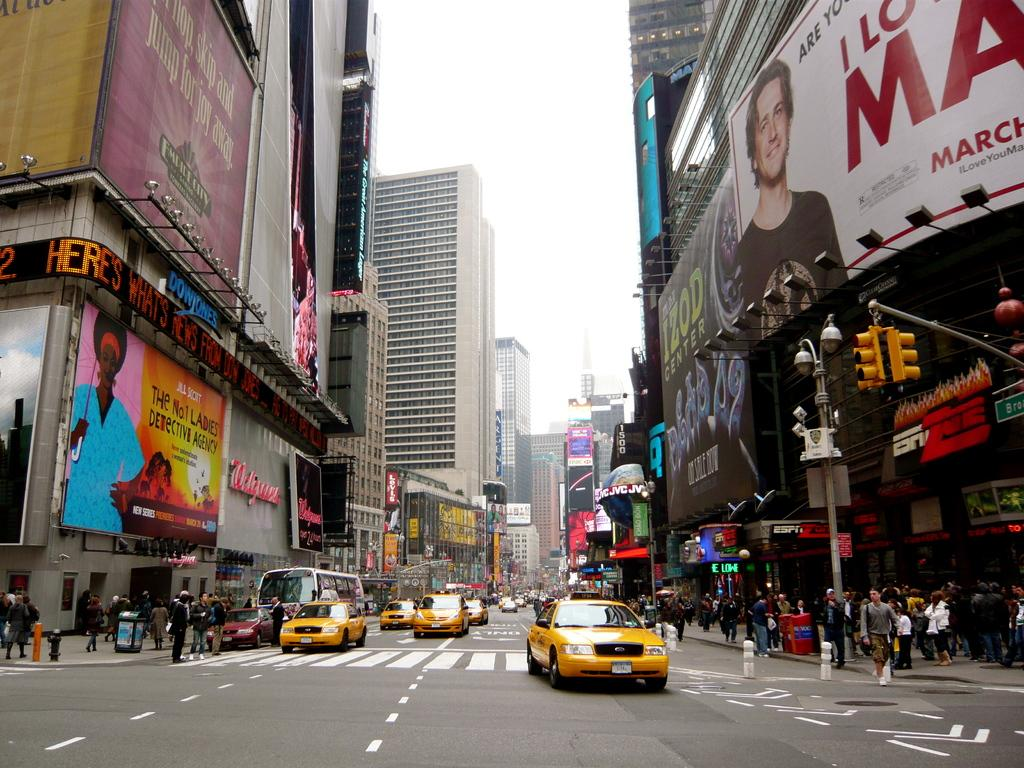<image>
Provide a brief description of the given image. a sign for the No. 1 Ladies Detective Agency 